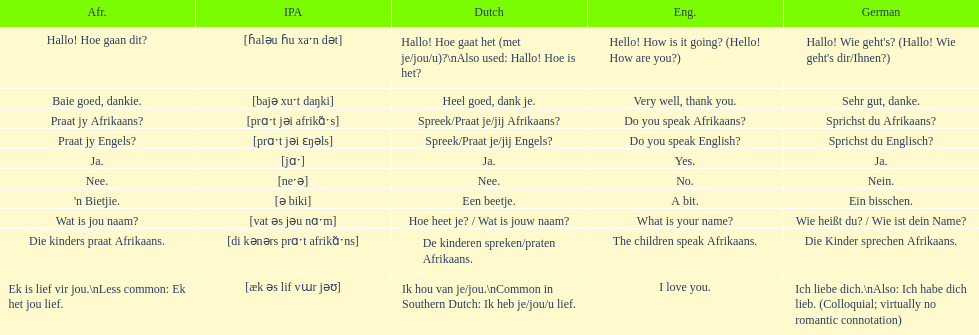How do you say "do you speak afrikaans?" in afrikaans? Praat jy Afrikaans?. 